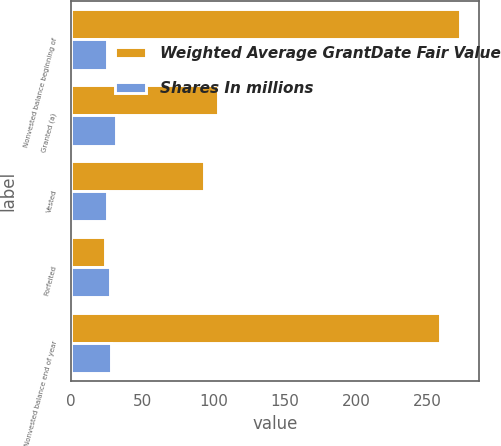<chart> <loc_0><loc_0><loc_500><loc_500><stacked_bar_chart><ecel><fcel>Nonvested balance beginning of<fcel>Granted (a)<fcel>Vested<fcel>Forfeited<fcel>Nonvested balance end of year<nl><fcel>Weighted Average GrantDate Fair Value<fcel>273<fcel>103<fcel>93<fcel>24<fcel>259<nl><fcel>Shares In millions<fcel>25.5<fcel>31.5<fcel>25.12<fcel>27.01<fcel>27.88<nl></chart> 